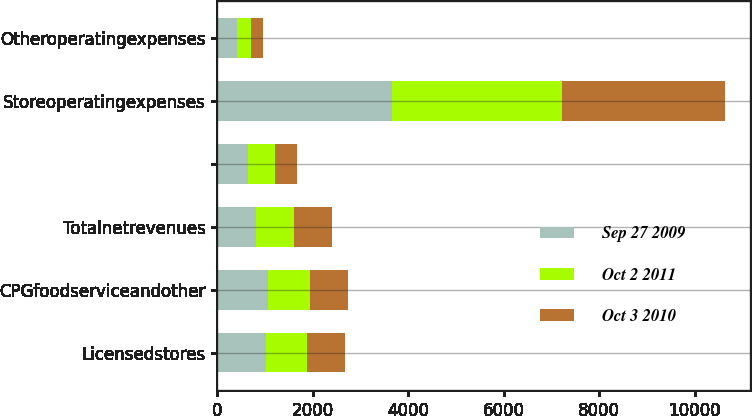Convert chart. <chart><loc_0><loc_0><loc_500><loc_500><stacked_bar_chart><ecel><fcel>Licensedstores<fcel>CPGfoodserviceandother<fcel>Totalnetrevenues<fcel>Unnamed: 4<fcel>Storeoperatingexpenses<fcel>Otheroperatingexpenses<nl><fcel>Sep 27 2009<fcel>1007.5<fcel>1060.5<fcel>799.5<fcel>636.1<fcel>3665.1<fcel>402<nl><fcel>Oct 2 2011<fcel>875.2<fcel>868.7<fcel>799.5<fcel>569.5<fcel>3551.4<fcel>293.2<nl><fcel>Oct 3 2010<fcel>795<fcel>799.5<fcel>799.5<fcel>453<fcel>3425.1<fcel>264.4<nl></chart> 